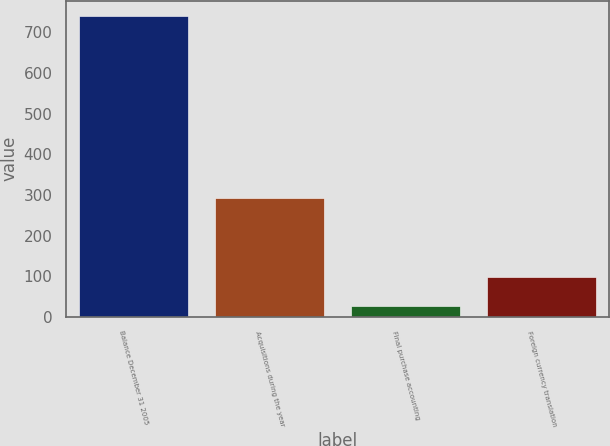Convert chart. <chart><loc_0><loc_0><loc_500><loc_500><bar_chart><fcel>Balance December 31 2005<fcel>Acquisitions during the year<fcel>Final purchase accounting<fcel>Foreign currency translation<nl><fcel>740.9<fcel>292.6<fcel>26.8<fcel>98.21<nl></chart> 